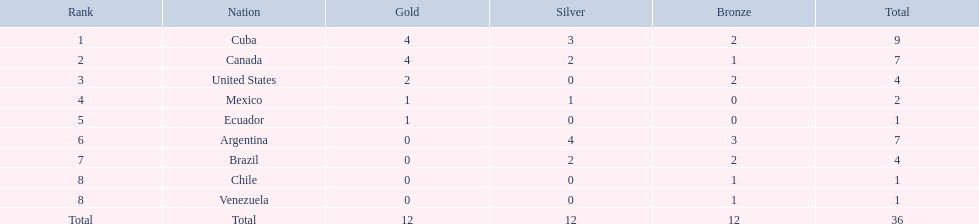What were the amounts of bronze medals won by the countries? 2, 1, 2, 0, 0, 3, 2, 1, 1. Which is the highest? 3. Which nation had this amount? Argentina. 